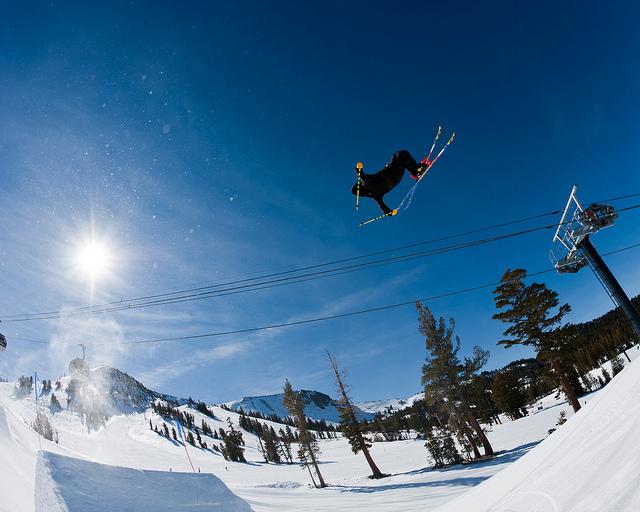Is this person going to land softly?
Write a very short answer. No. Is it cold?
Short answer required. Yes. Does this photo have lens flare?
Keep it brief. Yes. Is this person flying?
Quick response, please. Yes. 